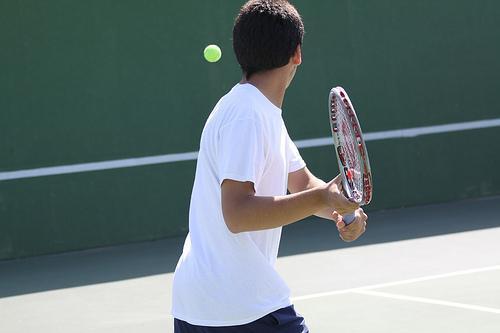How many men are there?
Give a very brief answer. 1. 